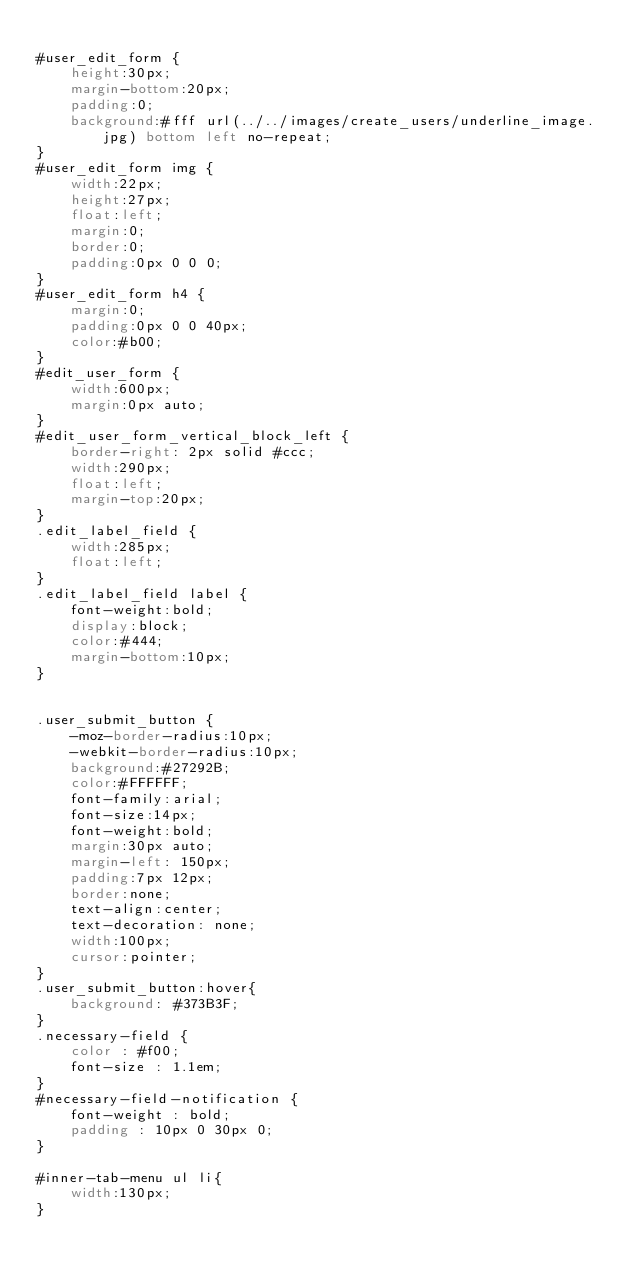<code> <loc_0><loc_0><loc_500><loc_500><_CSS_>
#user_edit_form {
    height:30px;
    margin-bottom:20px;
    padding:0;
    background:#fff url(../../images/create_users/underline_image.jpg) bottom left no-repeat;
}
#user_edit_form img {
    width:22px;
    height:27px;
    float:left;
    margin:0;
    border:0;
    padding:0px 0 0 0;
}
#user_edit_form h4 {
    margin:0;
    padding:0px 0 0 40px;
    color:#b00;
}
#edit_user_form {
    width:600px;
    margin:0px auto;
}
#edit_user_form_vertical_block_left {
    border-right: 2px solid #ccc;
    width:290px;
    float:left;
    margin-top:20px;
}
.edit_label_field {
    width:285px;
    float:left;
}
.edit_label_field label {
    font-weight:bold;
    display:block;
    color:#444;
    margin-bottom:10px;
}


.user_submit_button {
    -moz-border-radius:10px;
    -webkit-border-radius:10px;
    background:#27292B;
    color:#FFFFFF;
    font-family:arial;
    font-size:14px;
    font-weight:bold;
    margin:30px auto;
    margin-left: 150px;
    padding:7px 12px;
    border:none;
    text-align:center;
    text-decoration: none;
    width:100px;
    cursor:pointer;
}
.user_submit_button:hover{
    background: #373B3F;
}
.necessary-field {
    color : #f00;
    font-size : 1.1em;
}
#necessary-field-notification {
    font-weight : bold;
    padding : 10px 0 30px 0;
}

#inner-tab-menu ul li{
    width:130px;
}
</code> 